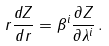Convert formula to latex. <formula><loc_0><loc_0><loc_500><loc_500>r \frac { d Z } { d r } = \beta ^ { i } \frac { \partial Z } { \partial \lambda ^ { i } } \, .</formula> 